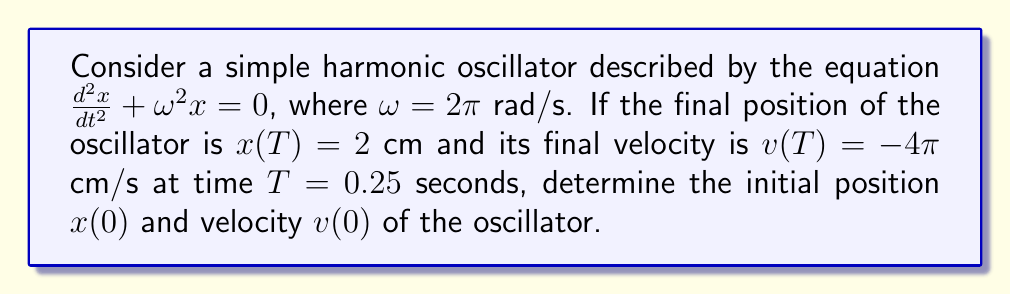What is the answer to this math problem? For a beginning coder, we can break this down into steps:

1) The general solution for a simple harmonic oscillator is:
   $x(t) = A \cos(\omega t) + B \sin(\omega t)$

2) The velocity is the derivative of position:
   $v(t) = \frac{dx}{dt} = -A\omega \sin(\omega t) + B\omega \cos(\omega t)$

3) We're given $\omega = 2\pi$ rad/s and $T = 0.25$ s. Let's substitute these:
   $x(0.25) = A \cos(2\pi \cdot 0.25) + B \sin(2\pi \cdot 0.25) = 2$
   $v(0.25) = -A\cdot 2\pi \sin(2\pi \cdot 0.25) + B\cdot 2\pi \cos(2\pi \cdot 0.25) = -4\pi$

4) Simplify using $\cos(\pi/2) = 0$ and $\sin(\pi/2) = 1$:
   $B = 2$
   $-A\cdot 2\pi = -4\pi$

5) Solve for A:
   $A = 2$

6) Now we have $x(t) = 2 \cos(2\pi t) + 2 \sin(2\pi t)$

7) To find $x(0)$, substitute $t = 0$:
   $x(0) = 2 \cos(0) + 2 \sin(0) = 2$ cm

8) For $v(0)$, use the velocity equation with $t = 0$:
   $v(0) = -2\cdot 2\pi \sin(0) + 2\cdot 2\pi \cos(0) = 4\pi$ cm/s

Therefore, the initial position is 2 cm and the initial velocity is $4\pi$ cm/s.
Answer: $x(0) = 2$ cm, $v(0) = 4\pi$ cm/s 